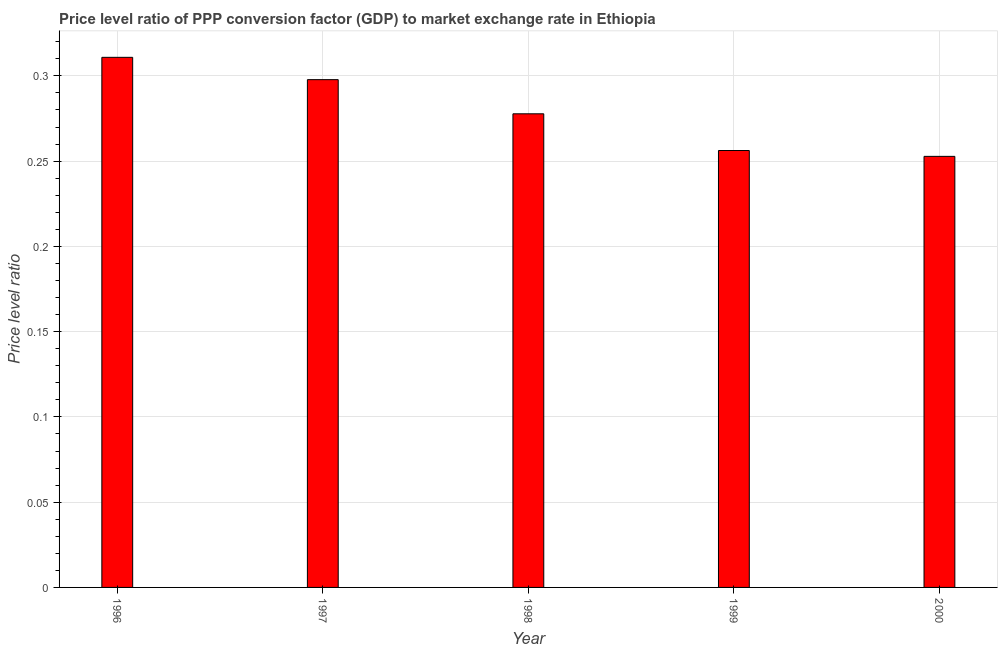Does the graph contain any zero values?
Keep it short and to the point. No. Does the graph contain grids?
Ensure brevity in your answer.  Yes. What is the title of the graph?
Make the answer very short. Price level ratio of PPP conversion factor (GDP) to market exchange rate in Ethiopia. What is the label or title of the Y-axis?
Your answer should be very brief. Price level ratio. What is the price level ratio in 1996?
Give a very brief answer. 0.31. Across all years, what is the maximum price level ratio?
Your answer should be very brief. 0.31. Across all years, what is the minimum price level ratio?
Your answer should be compact. 0.25. In which year was the price level ratio minimum?
Provide a short and direct response. 2000. What is the sum of the price level ratio?
Offer a terse response. 1.4. What is the difference between the price level ratio in 1998 and 1999?
Provide a short and direct response. 0.02. What is the average price level ratio per year?
Ensure brevity in your answer.  0.28. What is the median price level ratio?
Your response must be concise. 0.28. Do a majority of the years between 1998 and 1997 (inclusive) have price level ratio greater than 0.27 ?
Your response must be concise. No. What is the ratio of the price level ratio in 1999 to that in 2000?
Your answer should be very brief. 1.01. Is the price level ratio in 1996 less than that in 1999?
Your answer should be compact. No. Is the difference between the price level ratio in 1997 and 1999 greater than the difference between any two years?
Offer a very short reply. No. What is the difference between the highest and the second highest price level ratio?
Provide a short and direct response. 0.01. Is the sum of the price level ratio in 1998 and 1999 greater than the maximum price level ratio across all years?
Provide a succinct answer. Yes. In how many years, is the price level ratio greater than the average price level ratio taken over all years?
Make the answer very short. 2. How many years are there in the graph?
Ensure brevity in your answer.  5. Are the values on the major ticks of Y-axis written in scientific E-notation?
Offer a terse response. No. What is the Price level ratio of 1996?
Provide a short and direct response. 0.31. What is the Price level ratio in 1997?
Your answer should be compact. 0.3. What is the Price level ratio of 1998?
Provide a succinct answer. 0.28. What is the Price level ratio of 1999?
Your response must be concise. 0.26. What is the Price level ratio in 2000?
Make the answer very short. 0.25. What is the difference between the Price level ratio in 1996 and 1997?
Your answer should be very brief. 0.01. What is the difference between the Price level ratio in 1996 and 1998?
Ensure brevity in your answer.  0.03. What is the difference between the Price level ratio in 1996 and 1999?
Provide a short and direct response. 0.05. What is the difference between the Price level ratio in 1996 and 2000?
Your answer should be very brief. 0.06. What is the difference between the Price level ratio in 1997 and 1998?
Provide a short and direct response. 0.02. What is the difference between the Price level ratio in 1997 and 1999?
Keep it short and to the point. 0.04. What is the difference between the Price level ratio in 1997 and 2000?
Keep it short and to the point. 0.04. What is the difference between the Price level ratio in 1998 and 1999?
Give a very brief answer. 0.02. What is the difference between the Price level ratio in 1998 and 2000?
Make the answer very short. 0.02. What is the difference between the Price level ratio in 1999 and 2000?
Provide a succinct answer. 0. What is the ratio of the Price level ratio in 1996 to that in 1997?
Provide a short and direct response. 1.04. What is the ratio of the Price level ratio in 1996 to that in 1998?
Your response must be concise. 1.12. What is the ratio of the Price level ratio in 1996 to that in 1999?
Provide a short and direct response. 1.21. What is the ratio of the Price level ratio in 1996 to that in 2000?
Your response must be concise. 1.23. What is the ratio of the Price level ratio in 1997 to that in 1998?
Offer a terse response. 1.07. What is the ratio of the Price level ratio in 1997 to that in 1999?
Your answer should be very brief. 1.16. What is the ratio of the Price level ratio in 1997 to that in 2000?
Ensure brevity in your answer.  1.18. What is the ratio of the Price level ratio in 1998 to that in 1999?
Offer a very short reply. 1.08. What is the ratio of the Price level ratio in 1998 to that in 2000?
Provide a short and direct response. 1.1. 